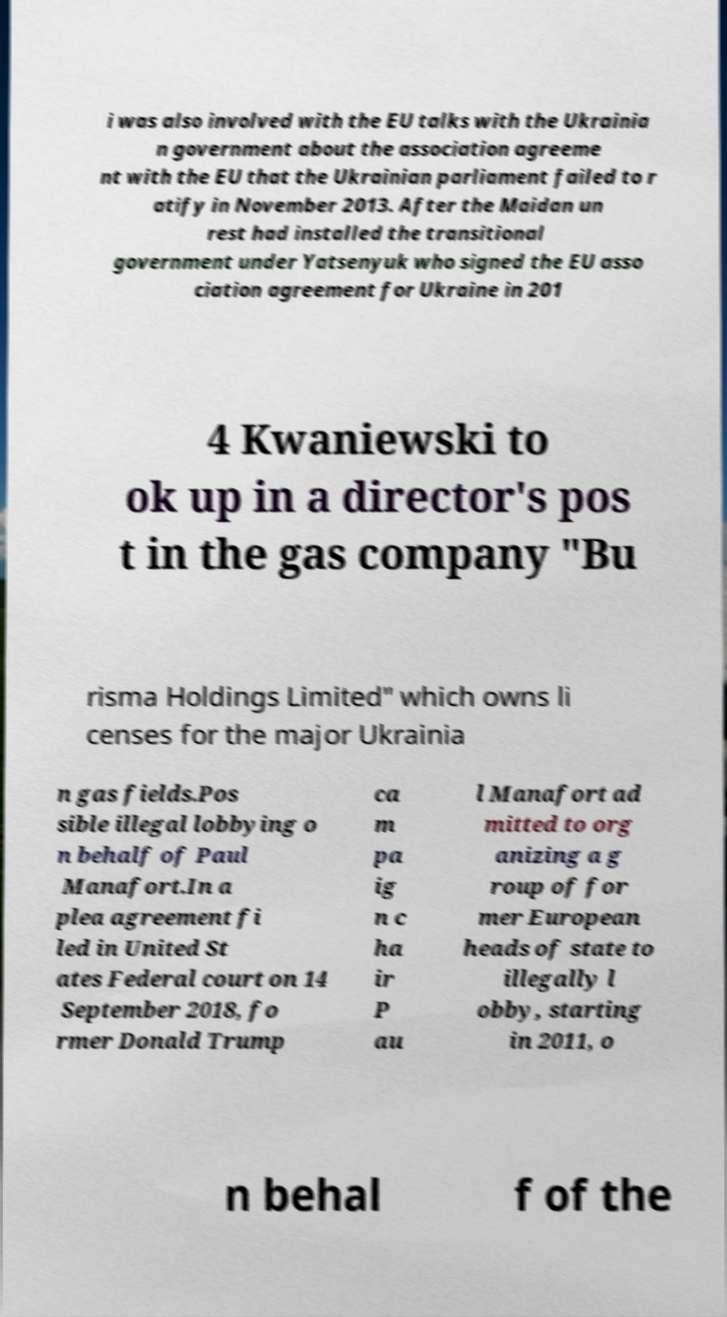Could you assist in decoding the text presented in this image and type it out clearly? i was also involved with the EU talks with the Ukrainia n government about the association agreeme nt with the EU that the Ukrainian parliament failed to r atify in November 2013. After the Maidan un rest had installed the transitional government under Yatsenyuk who signed the EU asso ciation agreement for Ukraine in 201 4 Kwaniewski to ok up in a director's pos t in the gas company ″Bu risma Holdings Limited″ which owns li censes for the major Ukrainia n gas fields.Pos sible illegal lobbying o n behalf of Paul Manafort.In a plea agreement fi led in United St ates Federal court on 14 September 2018, fo rmer Donald Trump ca m pa ig n c ha ir P au l Manafort ad mitted to org anizing a g roup of for mer European heads of state to illegally l obby, starting in 2011, o n behal f of the 